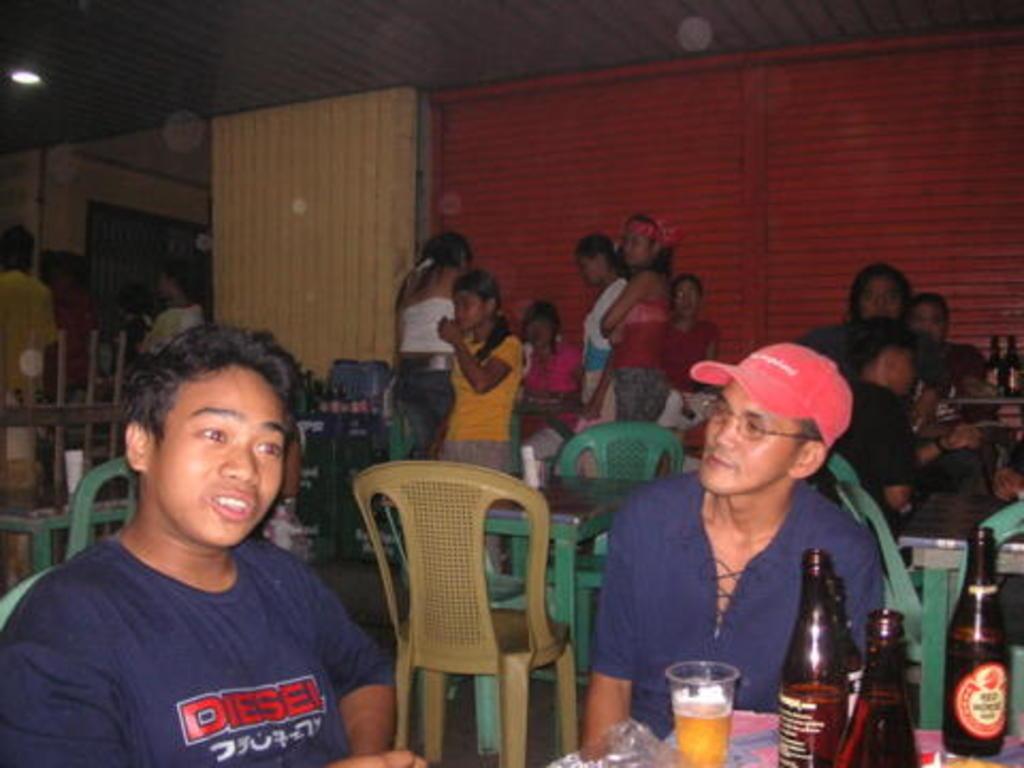Describe this image in one or two sentences. In this image, so many peoples are there. Few are sat on the chairs and few are standing here and here. We can see cream color wall and red color wall. Roof, we can see brown color. There is a light on the left corner. And few items are placed on the table at the bottom 